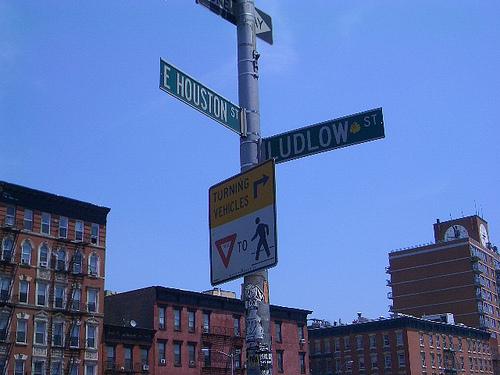How many stories is the tallest building in this scene?
Be succinct. 6. What street sign is on the right?
Concise answer only. Ludlow. Is this at an intersection?
Quick response, please. Yes. 